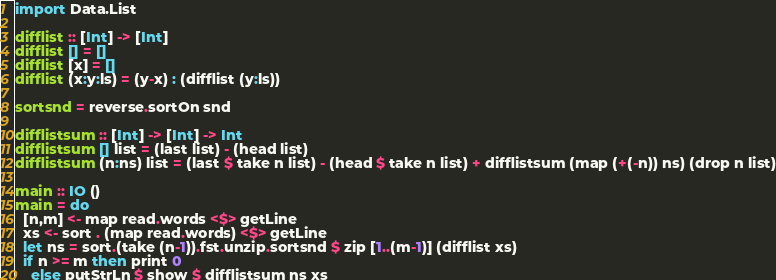<code> <loc_0><loc_0><loc_500><loc_500><_Haskell_>import Data.List
 
difflist :: [Int] -> [Int]
difflist [] = []
difflist [x] = []
difflist (x:y:ls) = (y-x) : (difflist (y:ls))
 
sortsnd = reverse.sortOn snd
 
difflistsum :: [Int] -> [Int] -> Int
difflistsum [] list = (last list) - (head list)
difflistsum (n:ns) list = (last $ take n list) - (head $ take n list) + difflistsum (map (+(-n)) ns) (drop n list)
 
main :: IO ()
main = do
  [n,m] <- map read.words <$> getLine
  xs <- sort . (map read.words) <$> getLine
  let ns = sort.(take (n-1)).fst.unzip.sortsnd $ zip [1..(m-1)] (difflist xs)
  if n >= m then print 0
    else putStrLn $ show $ difflistsum ns xs</code> 